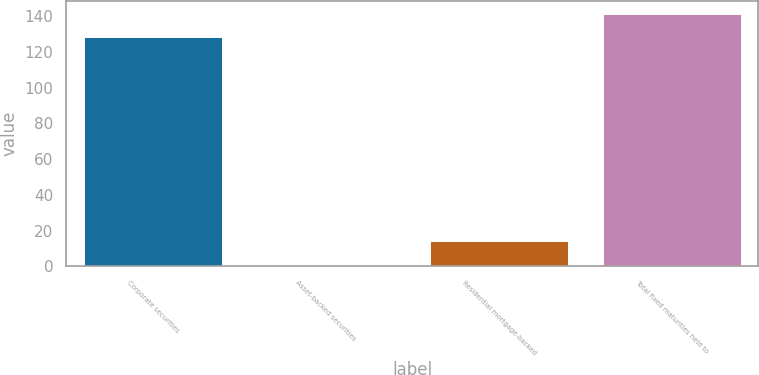<chart> <loc_0><loc_0><loc_500><loc_500><bar_chart><fcel>Corporate securities<fcel>Asset-backed securities<fcel>Residential mortgage-backed<fcel>Total fixed maturities held to<nl><fcel>128<fcel>1<fcel>14.2<fcel>141.2<nl></chart> 